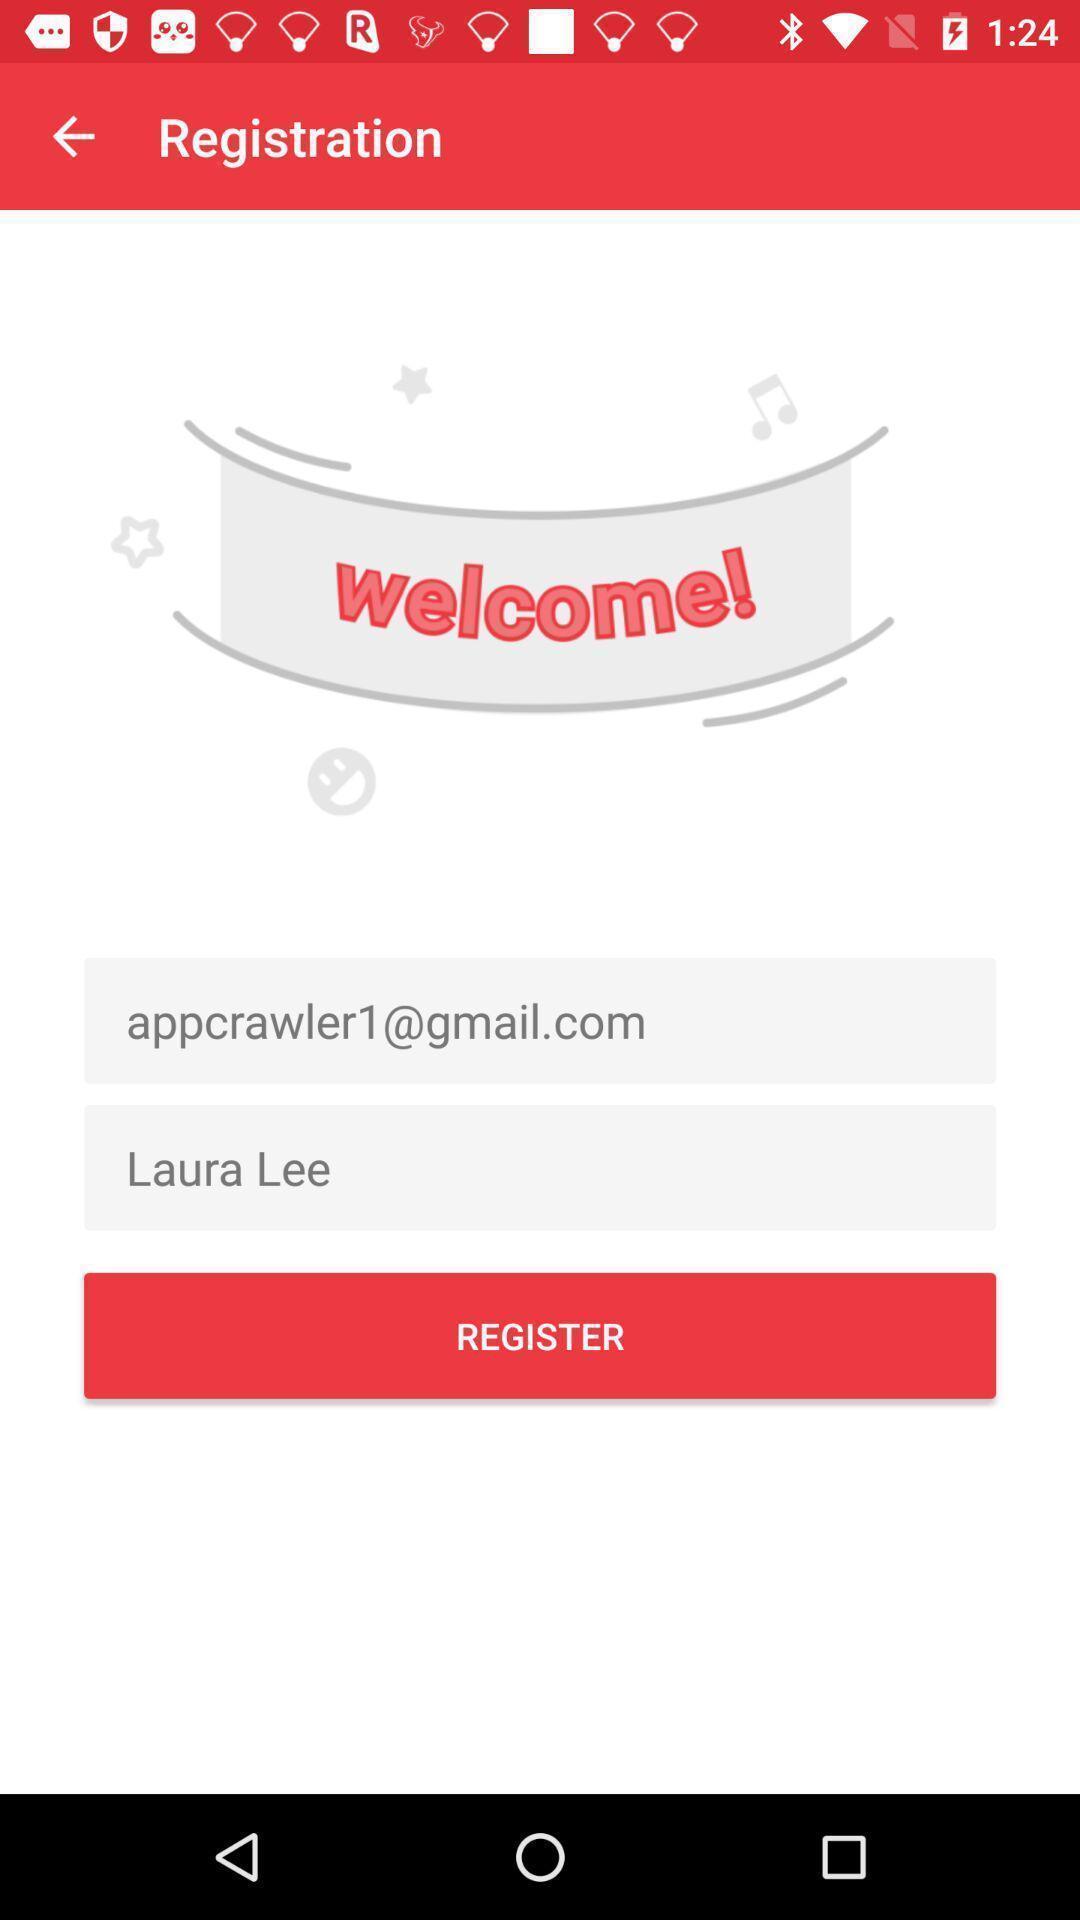Provide a textual representation of this image. Welcome page. 